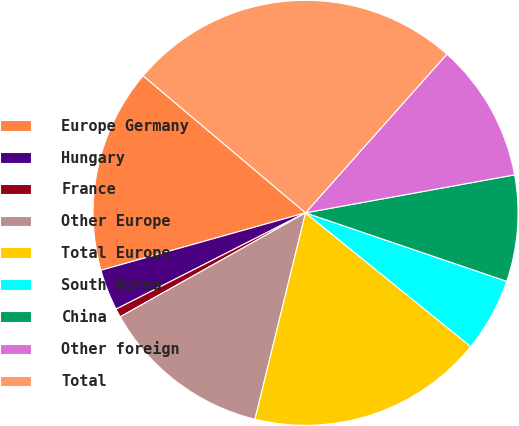Convert chart. <chart><loc_0><loc_0><loc_500><loc_500><pie_chart><fcel>Europe Germany<fcel>Hungary<fcel>France<fcel>Other Europe<fcel>Total Europe<fcel>South Korea<fcel>China<fcel>Other foreign<fcel>Total<nl><fcel>15.51%<fcel>3.13%<fcel>0.65%<fcel>13.04%<fcel>17.99%<fcel>5.61%<fcel>8.08%<fcel>10.56%<fcel>25.42%<nl></chart> 